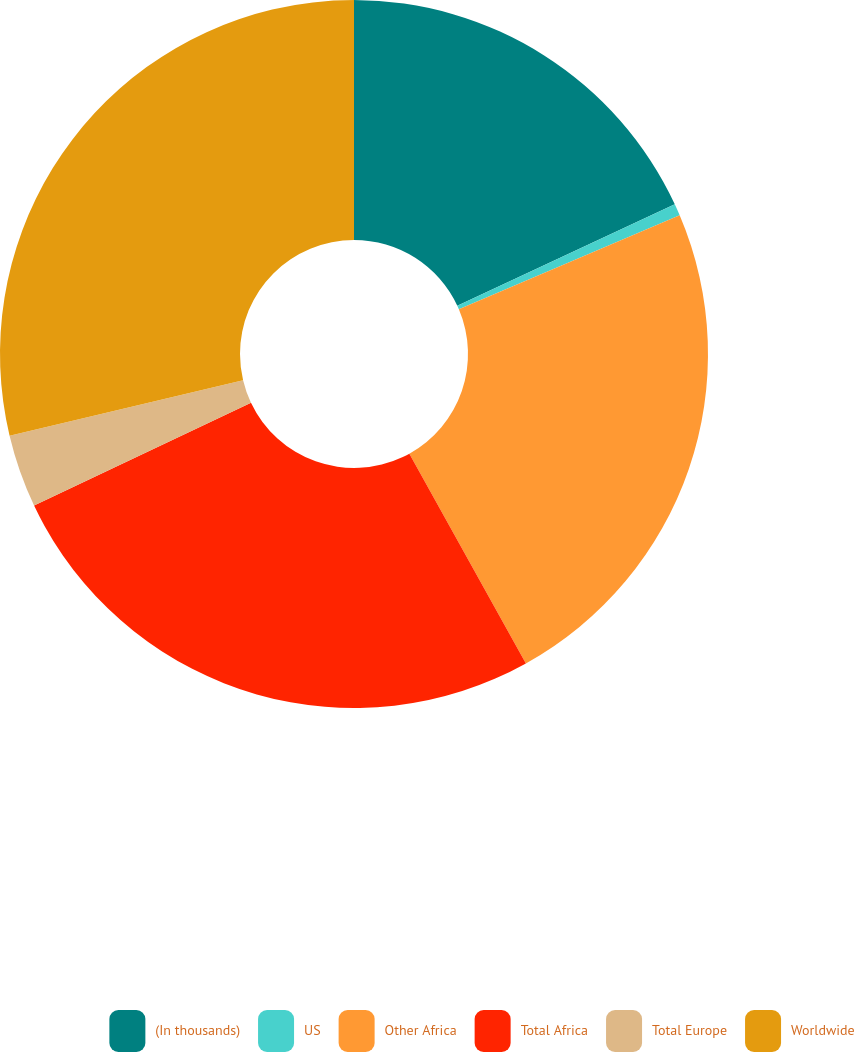Convert chart to OTSL. <chart><loc_0><loc_0><loc_500><loc_500><pie_chart><fcel>(In thousands)<fcel>US<fcel>Other Africa<fcel>Total Africa<fcel>Total Europe<fcel>Worldwide<nl><fcel>18.05%<fcel>0.54%<fcel>23.34%<fcel>26.03%<fcel>3.33%<fcel>28.71%<nl></chart> 